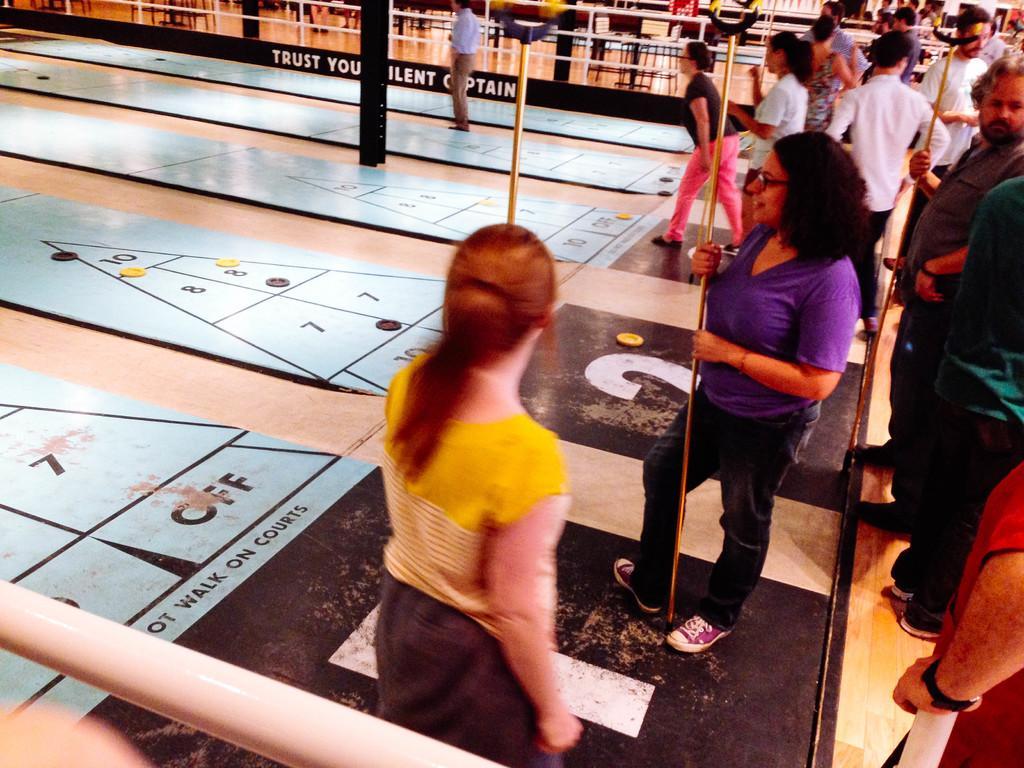How would you summarize this image in a sentence or two? In this image few people are playing some floor game. They are holding stick. In the background there are many chairs and tables. 